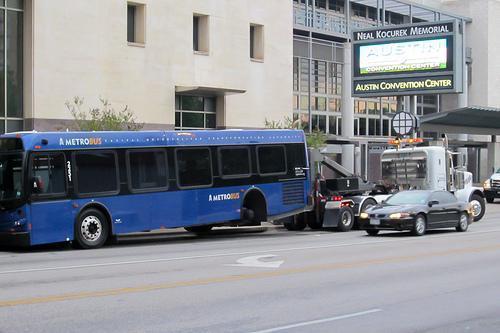How many cars are in the picture?
Give a very brief answer. 1. 